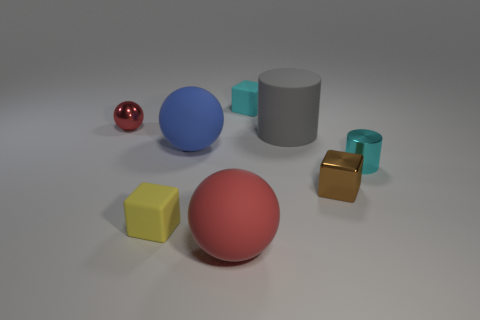Add 2 big green metallic cubes. How many objects exist? 10 Subtract all cylinders. How many objects are left? 6 Subtract 0 brown spheres. How many objects are left? 8 Subtract all tiny yellow things. Subtract all red cubes. How many objects are left? 7 Add 8 small yellow rubber objects. How many small yellow rubber objects are left? 9 Add 1 large purple metal things. How many large purple metal things exist? 1 